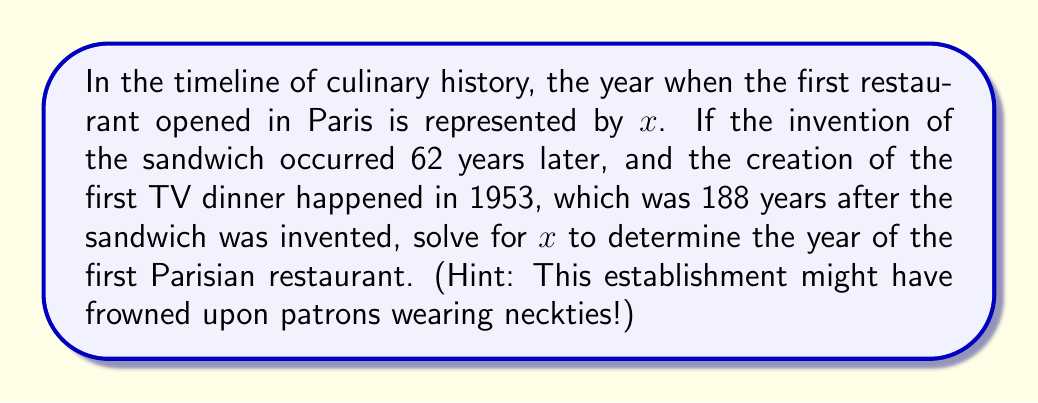Can you solve this math problem? Let's break this down step-by-step:

1) Let $x$ represent the year when the first restaurant opened in Paris.

2) The sandwich was invented 62 years later:
   $x + 62$ = Year of sandwich invention

3) The first TV dinner was created in 1953, which was 188 years after the sandwich:
   $(x + 62) + 188 = 1953$

4) Now we can solve for $x$:
   $x + 62 + 188 = 1953$
   $x + 250 = 1953$
   $x = 1953 - 250$
   $x = 1703$

Therefore, according to this timeline, the first restaurant in Paris opened in 1703.
Answer: 1703 